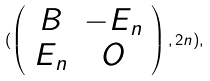Convert formula to latex. <formula><loc_0><loc_0><loc_500><loc_500>( \left ( \begin{array} { c c } B & - E _ { n } \\ E _ { n } & O \end{array} \right ) , 2 n ) ,</formula> 